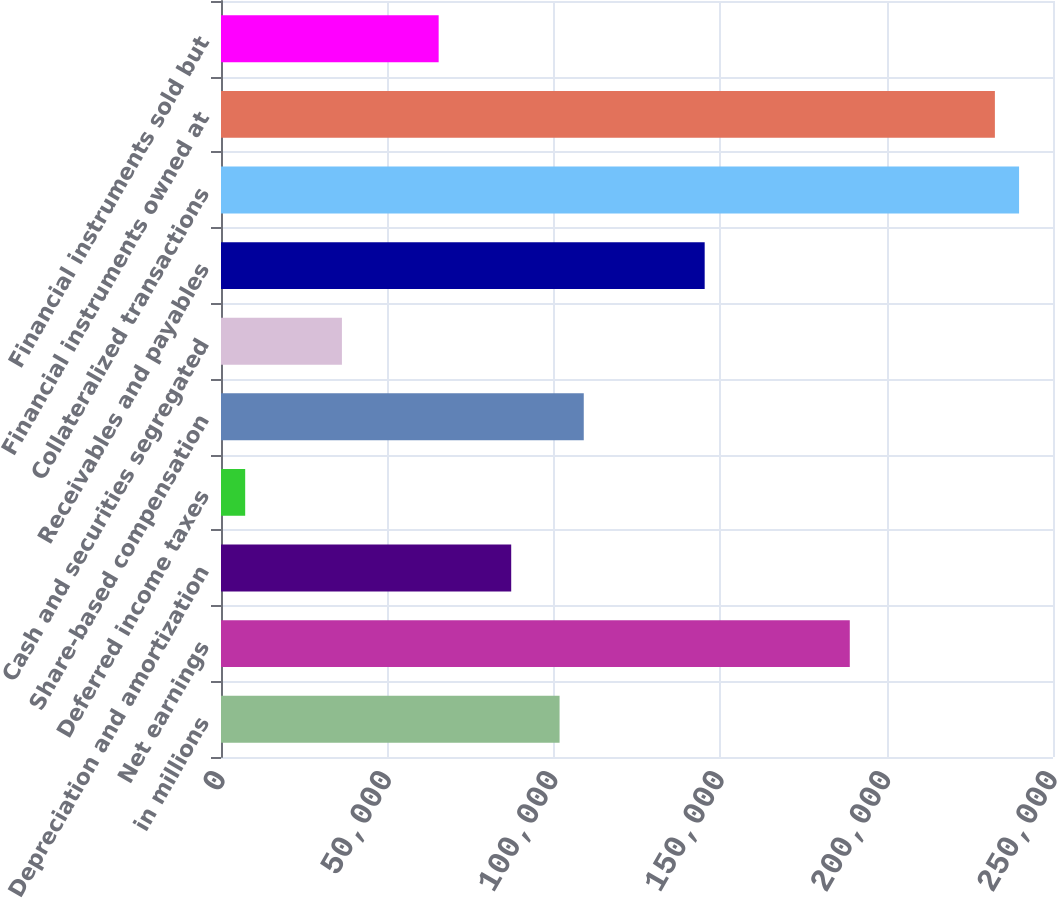Convert chart to OTSL. <chart><loc_0><loc_0><loc_500><loc_500><bar_chart><fcel>in millions<fcel>Net earnings<fcel>Depreciation and amortization<fcel>Deferred income taxes<fcel>Share-based compensation<fcel>Cash and securities segregated<fcel>Receivables and payables<fcel>Collateralized transactions<fcel>Financial instruments owned at<fcel>Financial instruments sold but<nl><fcel>101736<fcel>188938<fcel>87202.6<fcel>7267.8<fcel>109003<fcel>36335<fcel>145337<fcel>239805<fcel>232539<fcel>65402.2<nl></chart> 